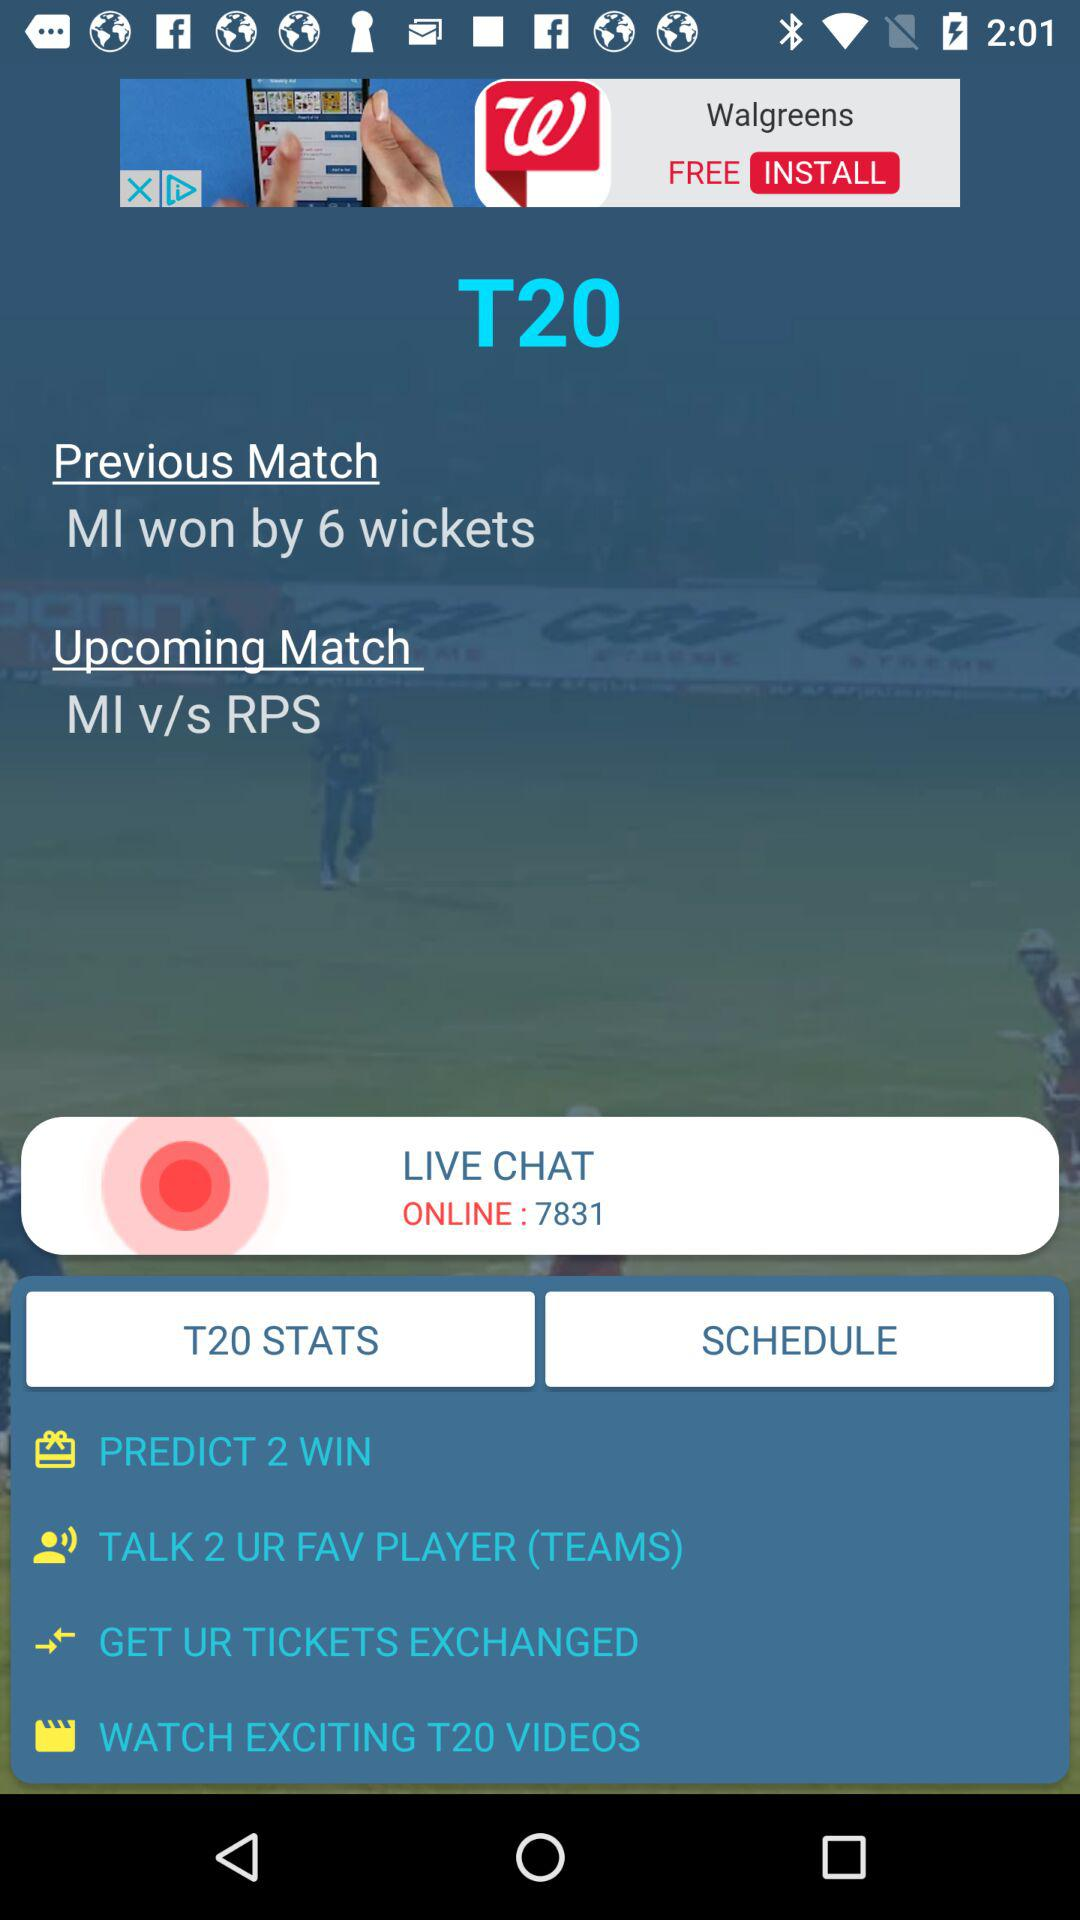What is the number of people online? The number of people online is 7831. 